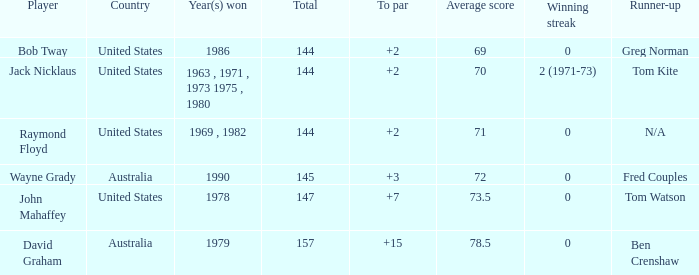How many strokes under par did the 1978 winner achieve? 7.0. 